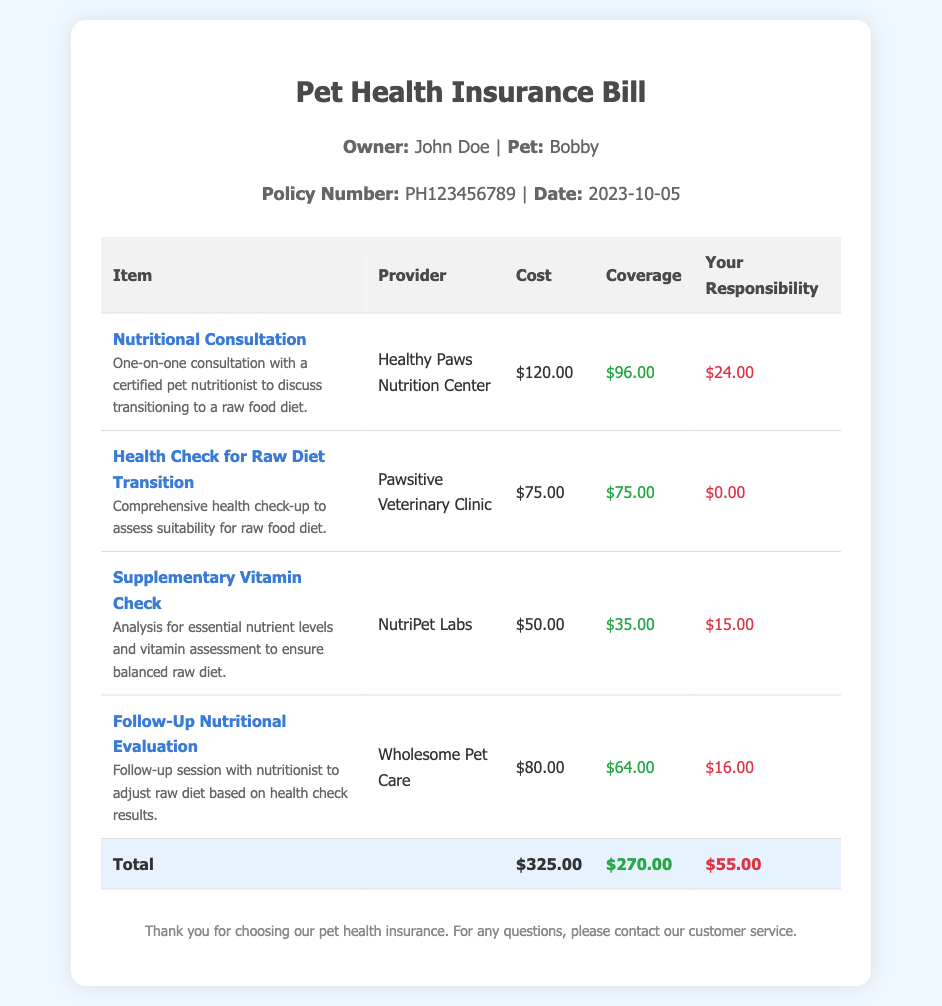What is the owner's name? The owner's name is listed in the pet information section of the document.
Answer: John Doe What is the policy number? The policy number can be found in the header section of the bill.
Answer: PH123456789 What is the cost of the nutritional consultation? The cost is listed next to the item in the table.
Answer: $120.00 What is the coverage amount for the health check? The coverage amount is noted in the coverage column of the table for the health check item.
Answer: $75.00 What is the total amount the owner is responsible for? The owner's responsibility is noted in the total row at the bottom of the bill.
Answer: $55.00 Which provider offers the follow-up nutritional evaluation? The provider's name is specified in the table for the corresponding service.
Answer: Wholesome Pet Care What is the purpose of the supplementary vitamin check? The purpose is described in the item description under the corresponding item in the table.
Answer: Analysis for essential nutrient levels and vitamin assessment How much is covered for the follow-up nutritional evaluation? The covered amount is listed in the coverage column of the table.
Answer: $64.00 What type of consultations are covered under this policy? The types of consultations can be found in the item descriptions in the document.
Answer: Nutritional Consultation, Follow-Up Nutritional Evaluation 